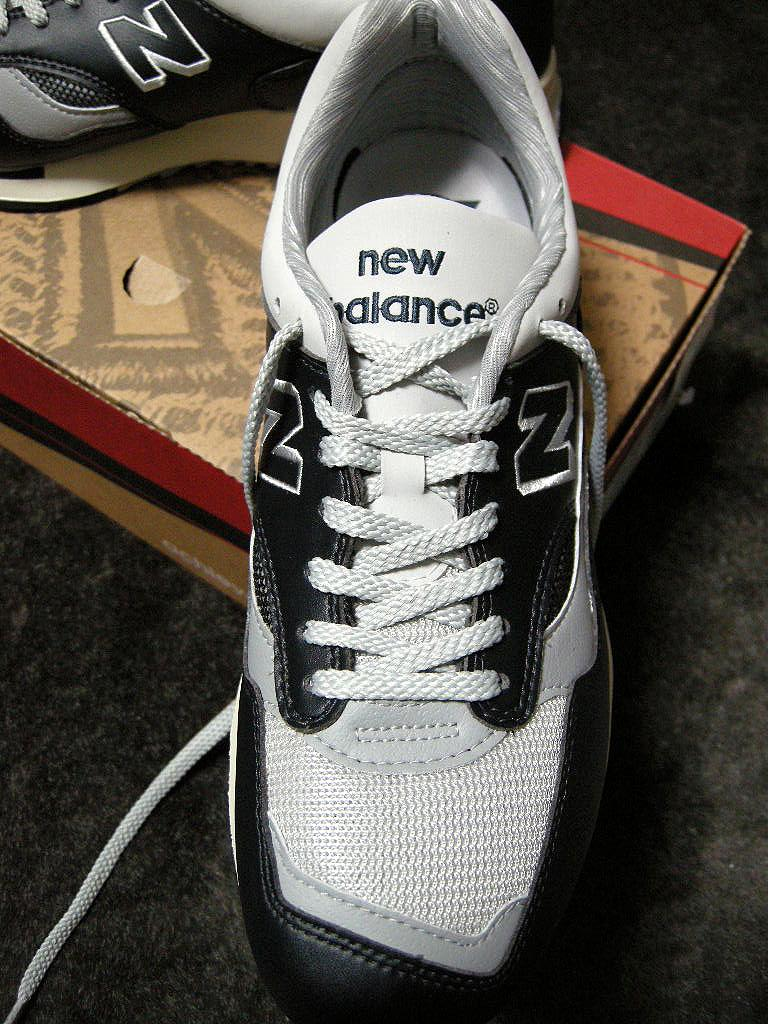What objects are in the image? There are shoes in the image. Where are the shoes placed? The shoes are on a cardboard box. What is the color of the shoes? The shoes are in white and black color. What is the background of the image? The box is on a grey surface. What finger is the queen using to point at the shoes in the image? There is no queen or finger present in the image; it only features shoes on a cardboard box. 